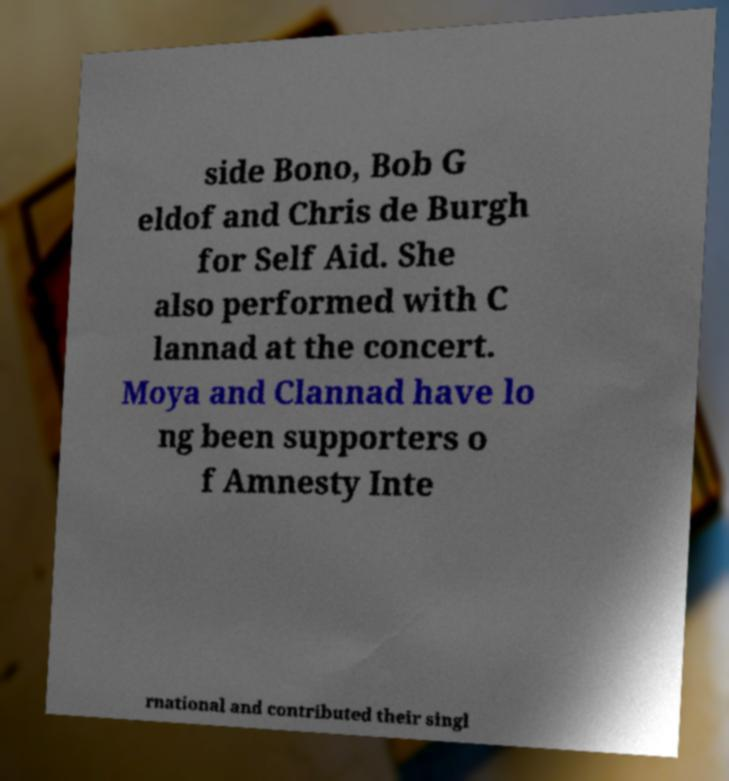Could you extract and type out the text from this image? side Bono, Bob G eldof and Chris de Burgh for Self Aid. She also performed with C lannad at the concert. Moya and Clannad have lo ng been supporters o f Amnesty Inte rnational and contributed their singl 